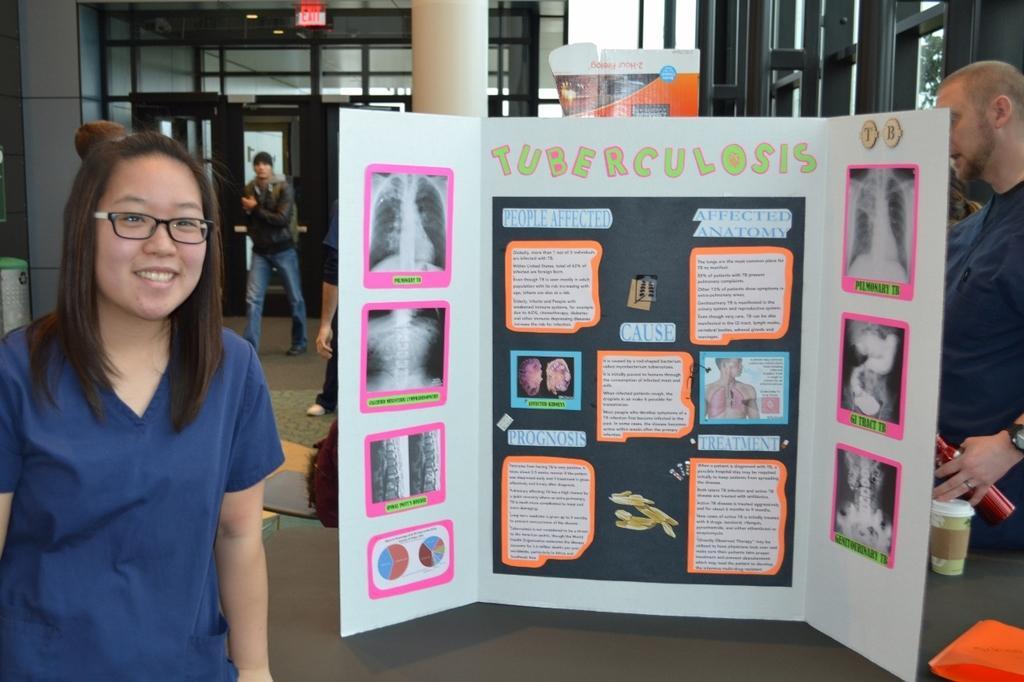Could you give a brief overview of what you see in this image? In the image there is a woman in the foreground and behind her there is a poster, behind the poster there is a pillar, windows, doors and few other people. 